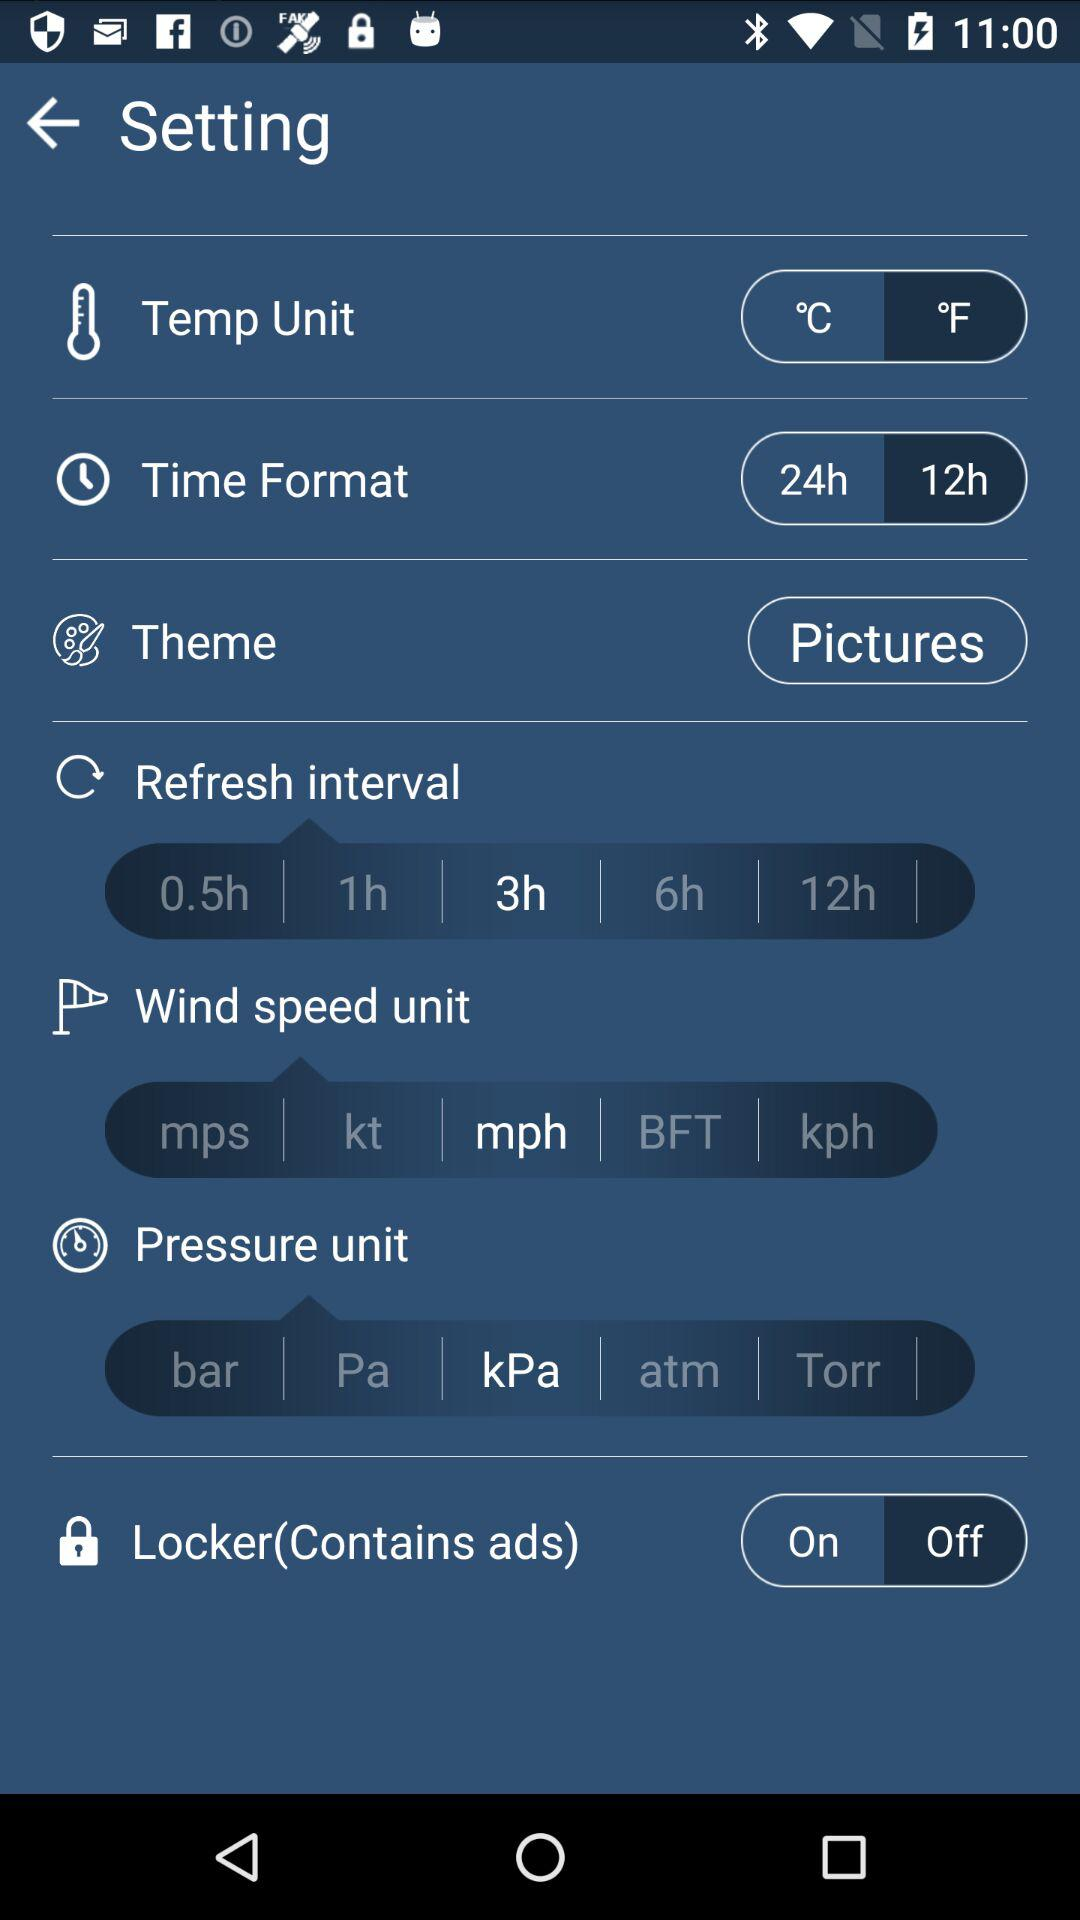How many options are there for the refresh interval?
Answer the question using a single word or phrase. 5 